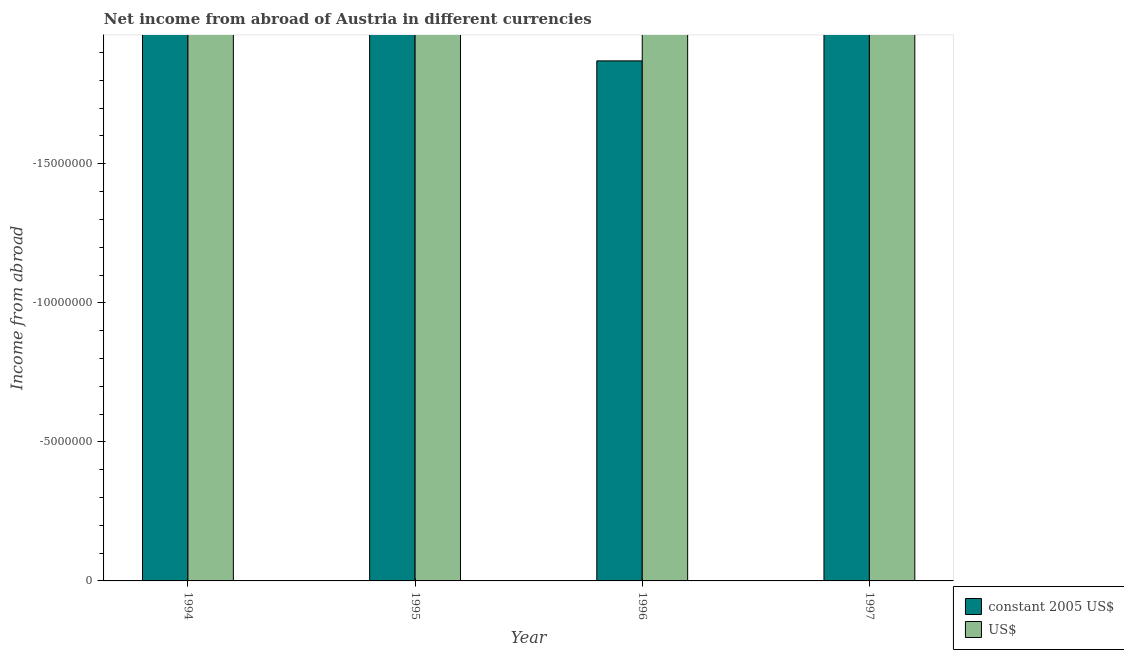Are the number of bars per tick equal to the number of legend labels?
Offer a very short reply. No. Are the number of bars on each tick of the X-axis equal?
Provide a short and direct response. Yes. How many bars are there on the 3rd tick from the right?
Give a very brief answer. 0. What is the label of the 3rd group of bars from the left?
Provide a succinct answer. 1996. In how many years, is the income from abroad in constant 2005 us$ greater than the average income from abroad in constant 2005 us$ taken over all years?
Your response must be concise. 0. How many years are there in the graph?
Your answer should be compact. 4. What is the difference between two consecutive major ticks on the Y-axis?
Offer a very short reply. 5.00e+06. Are the values on the major ticks of Y-axis written in scientific E-notation?
Your answer should be very brief. No. Does the graph contain any zero values?
Give a very brief answer. Yes. How many legend labels are there?
Provide a succinct answer. 2. What is the title of the graph?
Offer a very short reply. Net income from abroad of Austria in different currencies. Does "Agricultural land" appear as one of the legend labels in the graph?
Your answer should be compact. No. What is the label or title of the Y-axis?
Provide a short and direct response. Income from abroad. What is the Income from abroad of US$ in 1994?
Ensure brevity in your answer.  0. What is the Income from abroad in US$ in 1995?
Make the answer very short. 0. What is the Income from abroad of US$ in 1996?
Your answer should be compact. 0. What is the Income from abroad of constant 2005 US$ in 1997?
Provide a succinct answer. 0. What is the total Income from abroad of constant 2005 US$ in the graph?
Give a very brief answer. 0. What is the total Income from abroad of US$ in the graph?
Your answer should be compact. 0. What is the average Income from abroad in constant 2005 US$ per year?
Give a very brief answer. 0. 